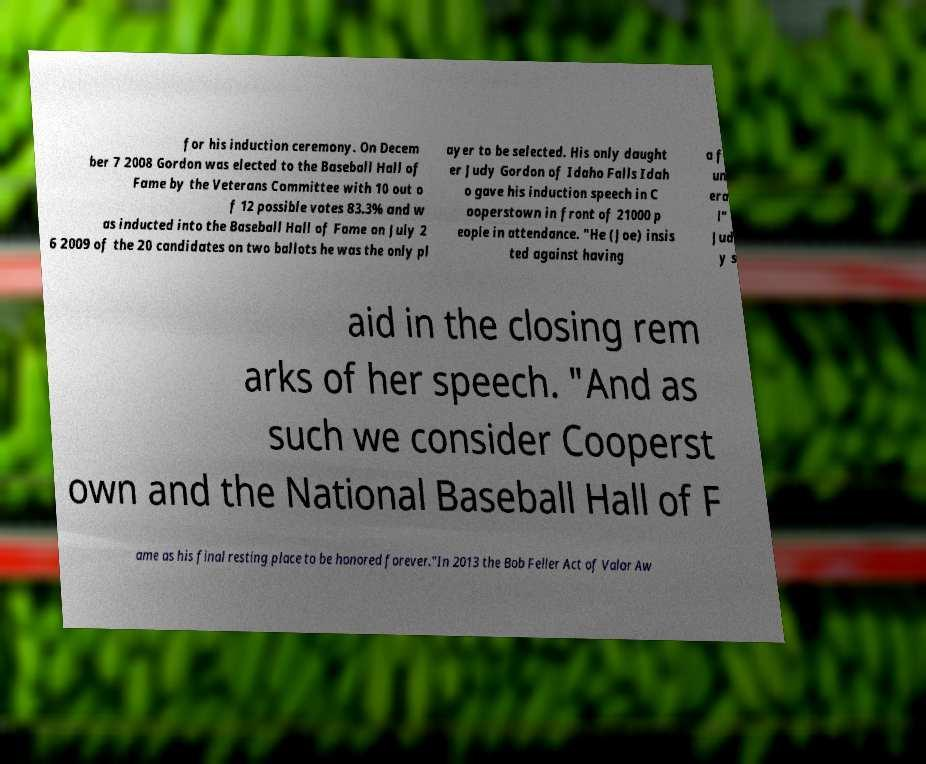I need the written content from this picture converted into text. Can you do that? for his induction ceremony. On Decem ber 7 2008 Gordon was elected to the Baseball Hall of Fame by the Veterans Committee with 10 out o f 12 possible votes 83.3% and w as inducted into the Baseball Hall of Fame on July 2 6 2009 of the 20 candidates on two ballots he was the only pl ayer to be selected. His only daught er Judy Gordon of Idaho Falls Idah o gave his induction speech in C ooperstown in front of 21000 p eople in attendance. "He (Joe) insis ted against having a f un era l" Jud y s aid in the closing rem arks of her speech. "And as such we consider Cooperst own and the National Baseball Hall of F ame as his final resting place to be honored forever."In 2013 the Bob Feller Act of Valor Aw 